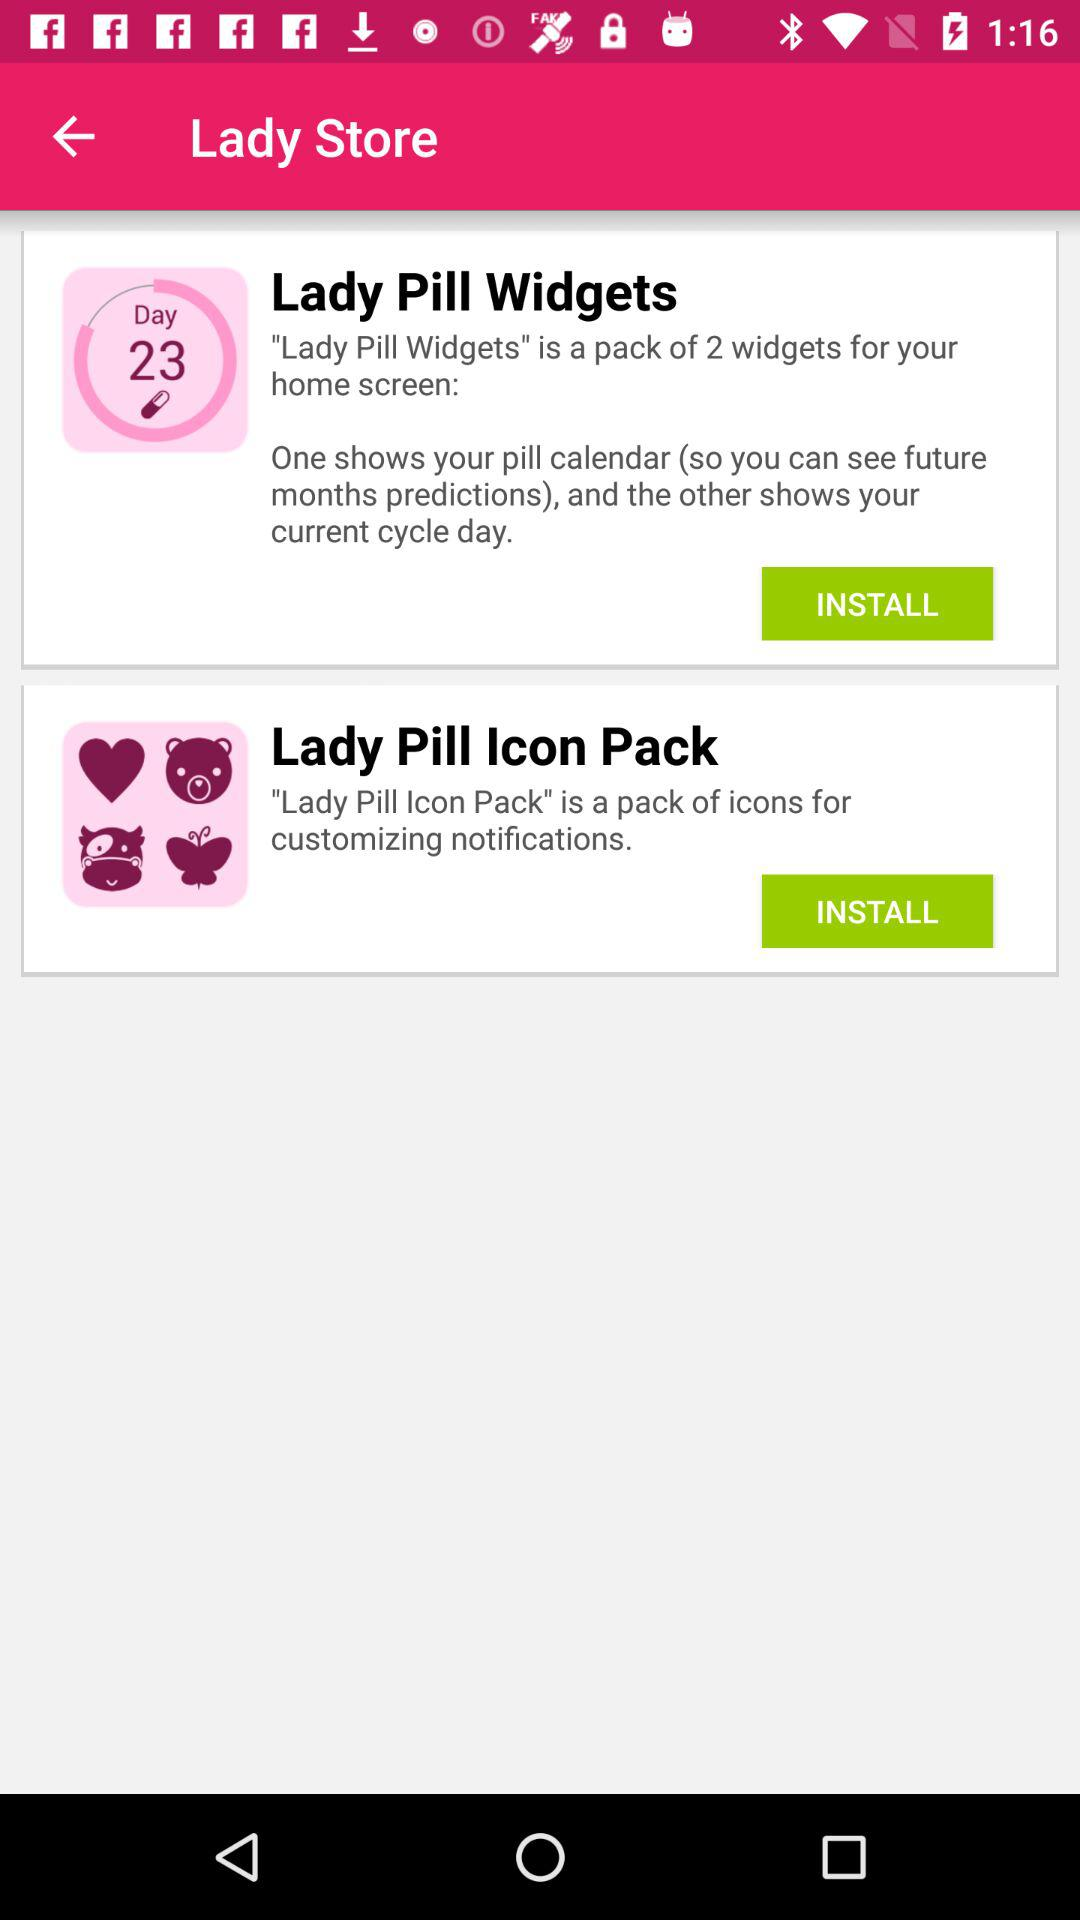What is the application name? The application names are "Lady Pill Widgets" and "Lady Pill Icon Pack". 